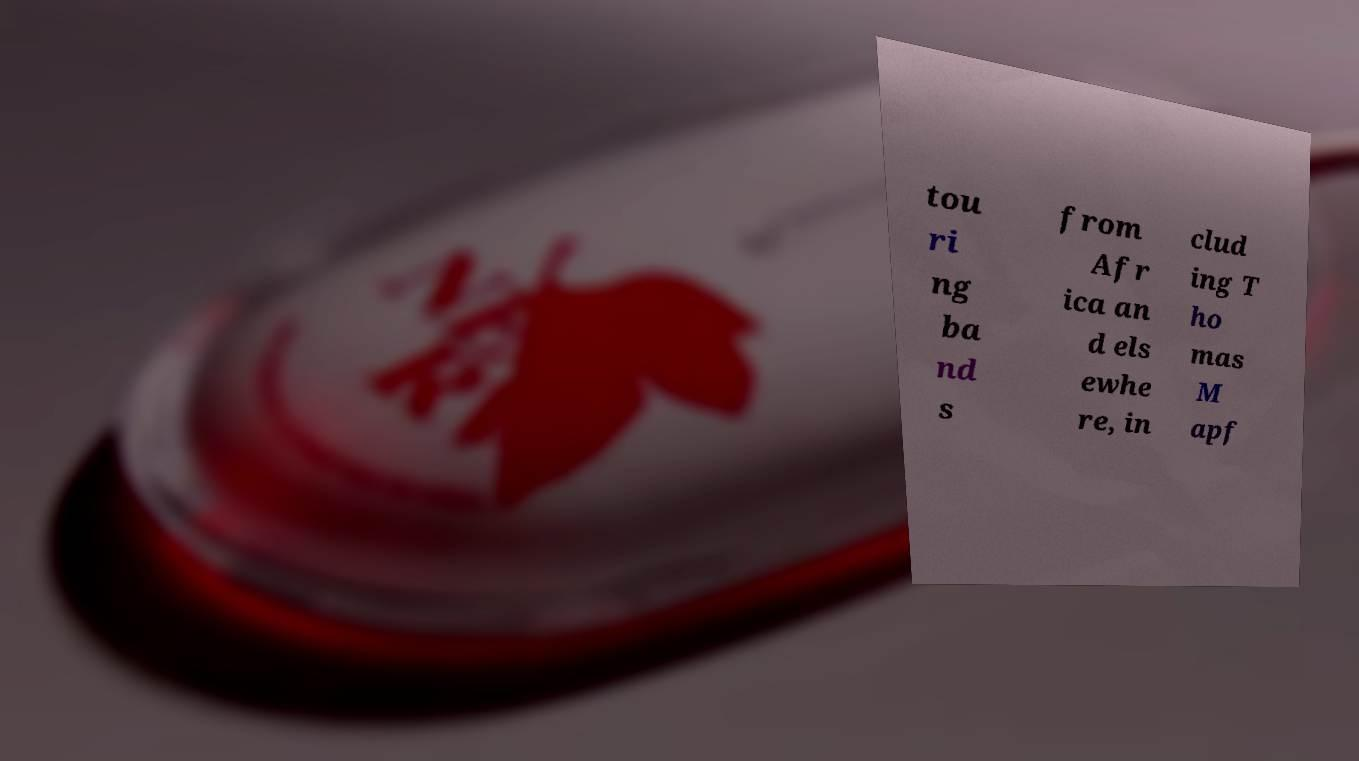For documentation purposes, I need the text within this image transcribed. Could you provide that? tou ri ng ba nd s from Afr ica an d els ewhe re, in clud ing T ho mas M apf 